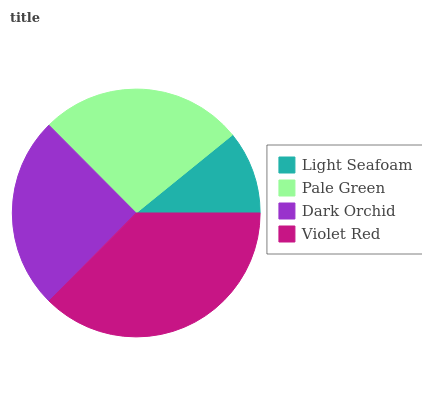Is Light Seafoam the minimum?
Answer yes or no. Yes. Is Violet Red the maximum?
Answer yes or no. Yes. Is Pale Green the minimum?
Answer yes or no. No. Is Pale Green the maximum?
Answer yes or no. No. Is Pale Green greater than Light Seafoam?
Answer yes or no. Yes. Is Light Seafoam less than Pale Green?
Answer yes or no. Yes. Is Light Seafoam greater than Pale Green?
Answer yes or no. No. Is Pale Green less than Light Seafoam?
Answer yes or no. No. Is Pale Green the high median?
Answer yes or no. Yes. Is Dark Orchid the low median?
Answer yes or no. Yes. Is Violet Red the high median?
Answer yes or no. No. Is Light Seafoam the low median?
Answer yes or no. No. 